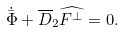Convert formula to latex. <formula><loc_0><loc_0><loc_500><loc_500>\dot { \bar { \Phi } } + \overline { D } _ { 2 } \widehat { F ^ { \perp } } = 0 .</formula> 